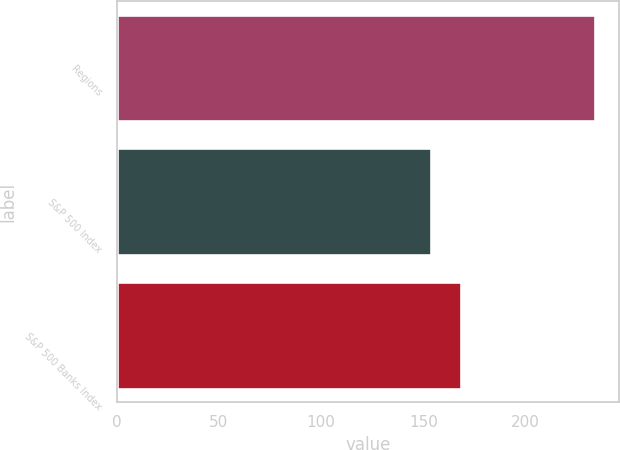Convert chart. <chart><loc_0><loc_0><loc_500><loc_500><bar_chart><fcel>Regions<fcel>S&P 500 Index<fcel>S&P 500 Banks Index<nl><fcel>233.92<fcel>153.54<fcel>168.37<nl></chart> 